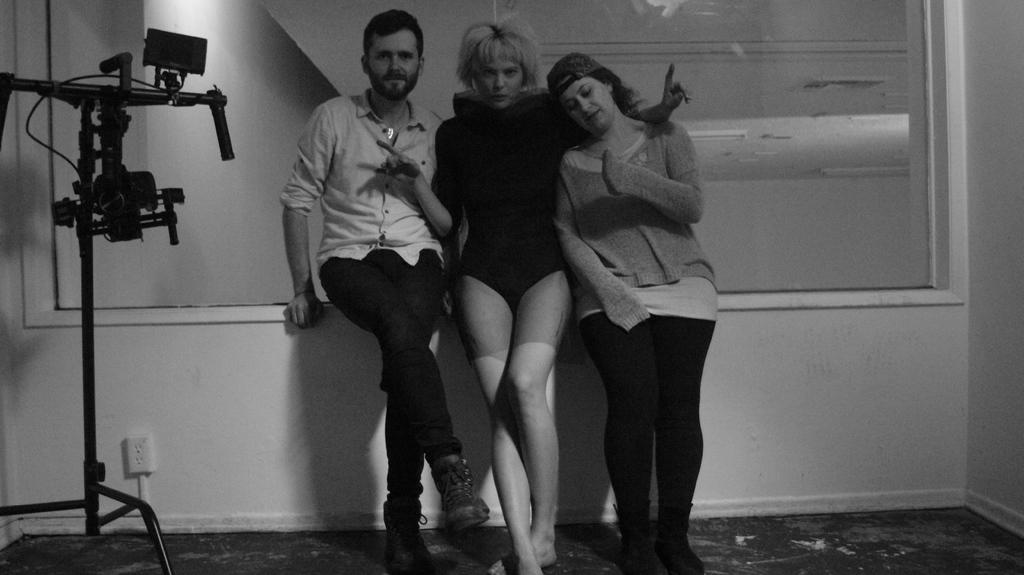What is the color scheme of the image? The image is black and white. What can be seen in the center of the image? There are persons on the floor in the center of the image. What is visible in the background of the image? There is a wall in the background of the image. What type of creature is interacting with the persons on the floor in the image? There is no creature present in the image; it only features persons on the floor and a wall in the background. Can you tell me how many parents are visible in the image? There is no reference to parents in the image, as it only shows persons on the floor and a wall in the background. 